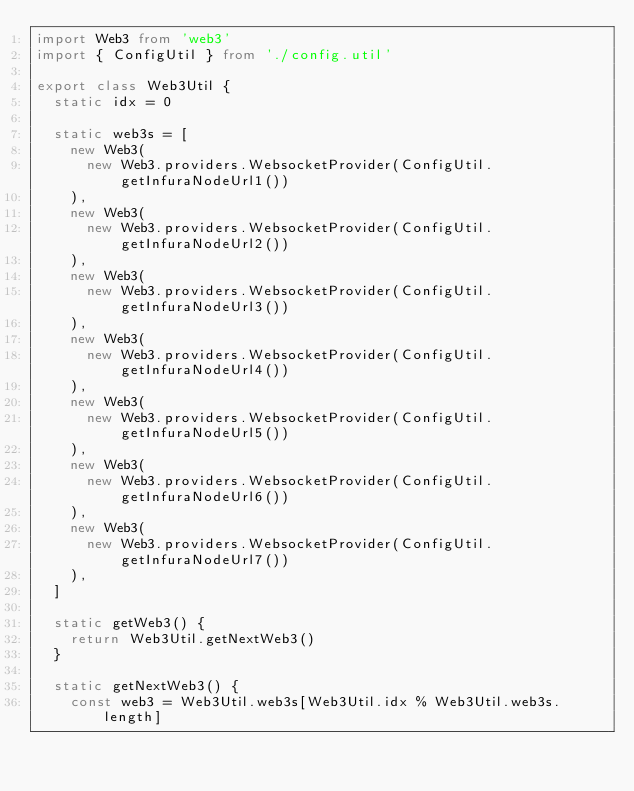Convert code to text. <code><loc_0><loc_0><loc_500><loc_500><_TypeScript_>import Web3 from 'web3'
import { ConfigUtil } from './config.util'

export class Web3Util {
  static idx = 0

  static web3s = [
    new Web3(
      new Web3.providers.WebsocketProvider(ConfigUtil.getInfuraNodeUrl1())
    ),
    new Web3(
      new Web3.providers.WebsocketProvider(ConfigUtil.getInfuraNodeUrl2())
    ),
    new Web3(
      new Web3.providers.WebsocketProvider(ConfigUtil.getInfuraNodeUrl3())
    ),
    new Web3(
      new Web3.providers.WebsocketProvider(ConfigUtil.getInfuraNodeUrl4())
    ),
    new Web3(
      new Web3.providers.WebsocketProvider(ConfigUtil.getInfuraNodeUrl5())
    ),
    new Web3(
      new Web3.providers.WebsocketProvider(ConfigUtil.getInfuraNodeUrl6())
    ),
    new Web3(
      new Web3.providers.WebsocketProvider(ConfigUtil.getInfuraNodeUrl7())
    ),
  ]

  static getWeb3() {
    return Web3Util.getNextWeb3()
  }

  static getNextWeb3() {
    const web3 = Web3Util.web3s[Web3Util.idx % Web3Util.web3s.length]</code> 